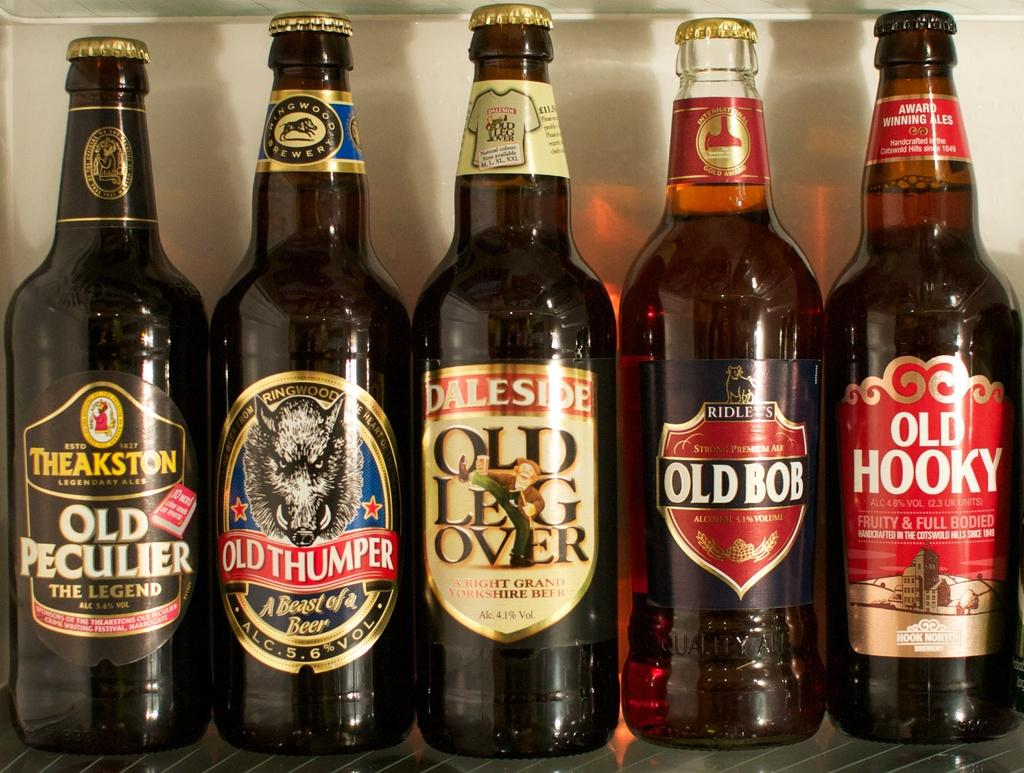<image>
Offer a succinct explanation of the picture presented. Fivecraft beers with quirky names like Old Bob and Old Hooky stand side by side. 